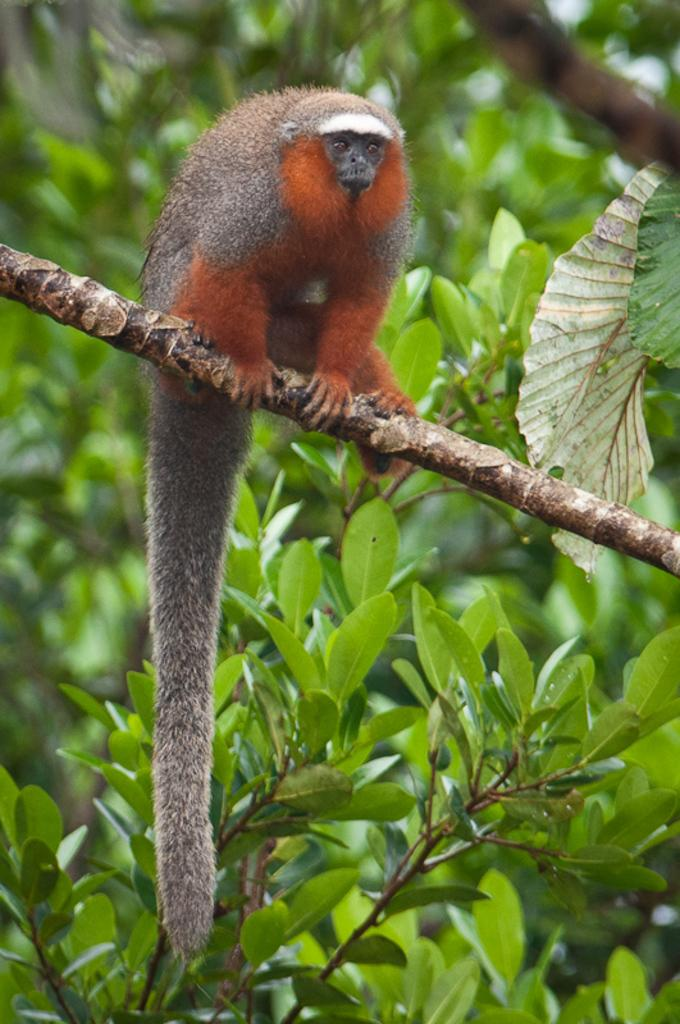What is the main subject in the foreground of the image? There is a monkey in the foreground of the image. Where is the monkey located? The monkey is on a branch of a tree. What physical feature does the monkey have? The monkey has a long tail. What country is the monkey fighting for in the image? There is no indication in the image that the monkey is fighting or representing any country. 